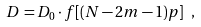Convert formula to latex. <formula><loc_0><loc_0><loc_500><loc_500>D = D _ { 0 } \cdot f [ ( N - 2 m - 1 ) p ] \ ,</formula> 